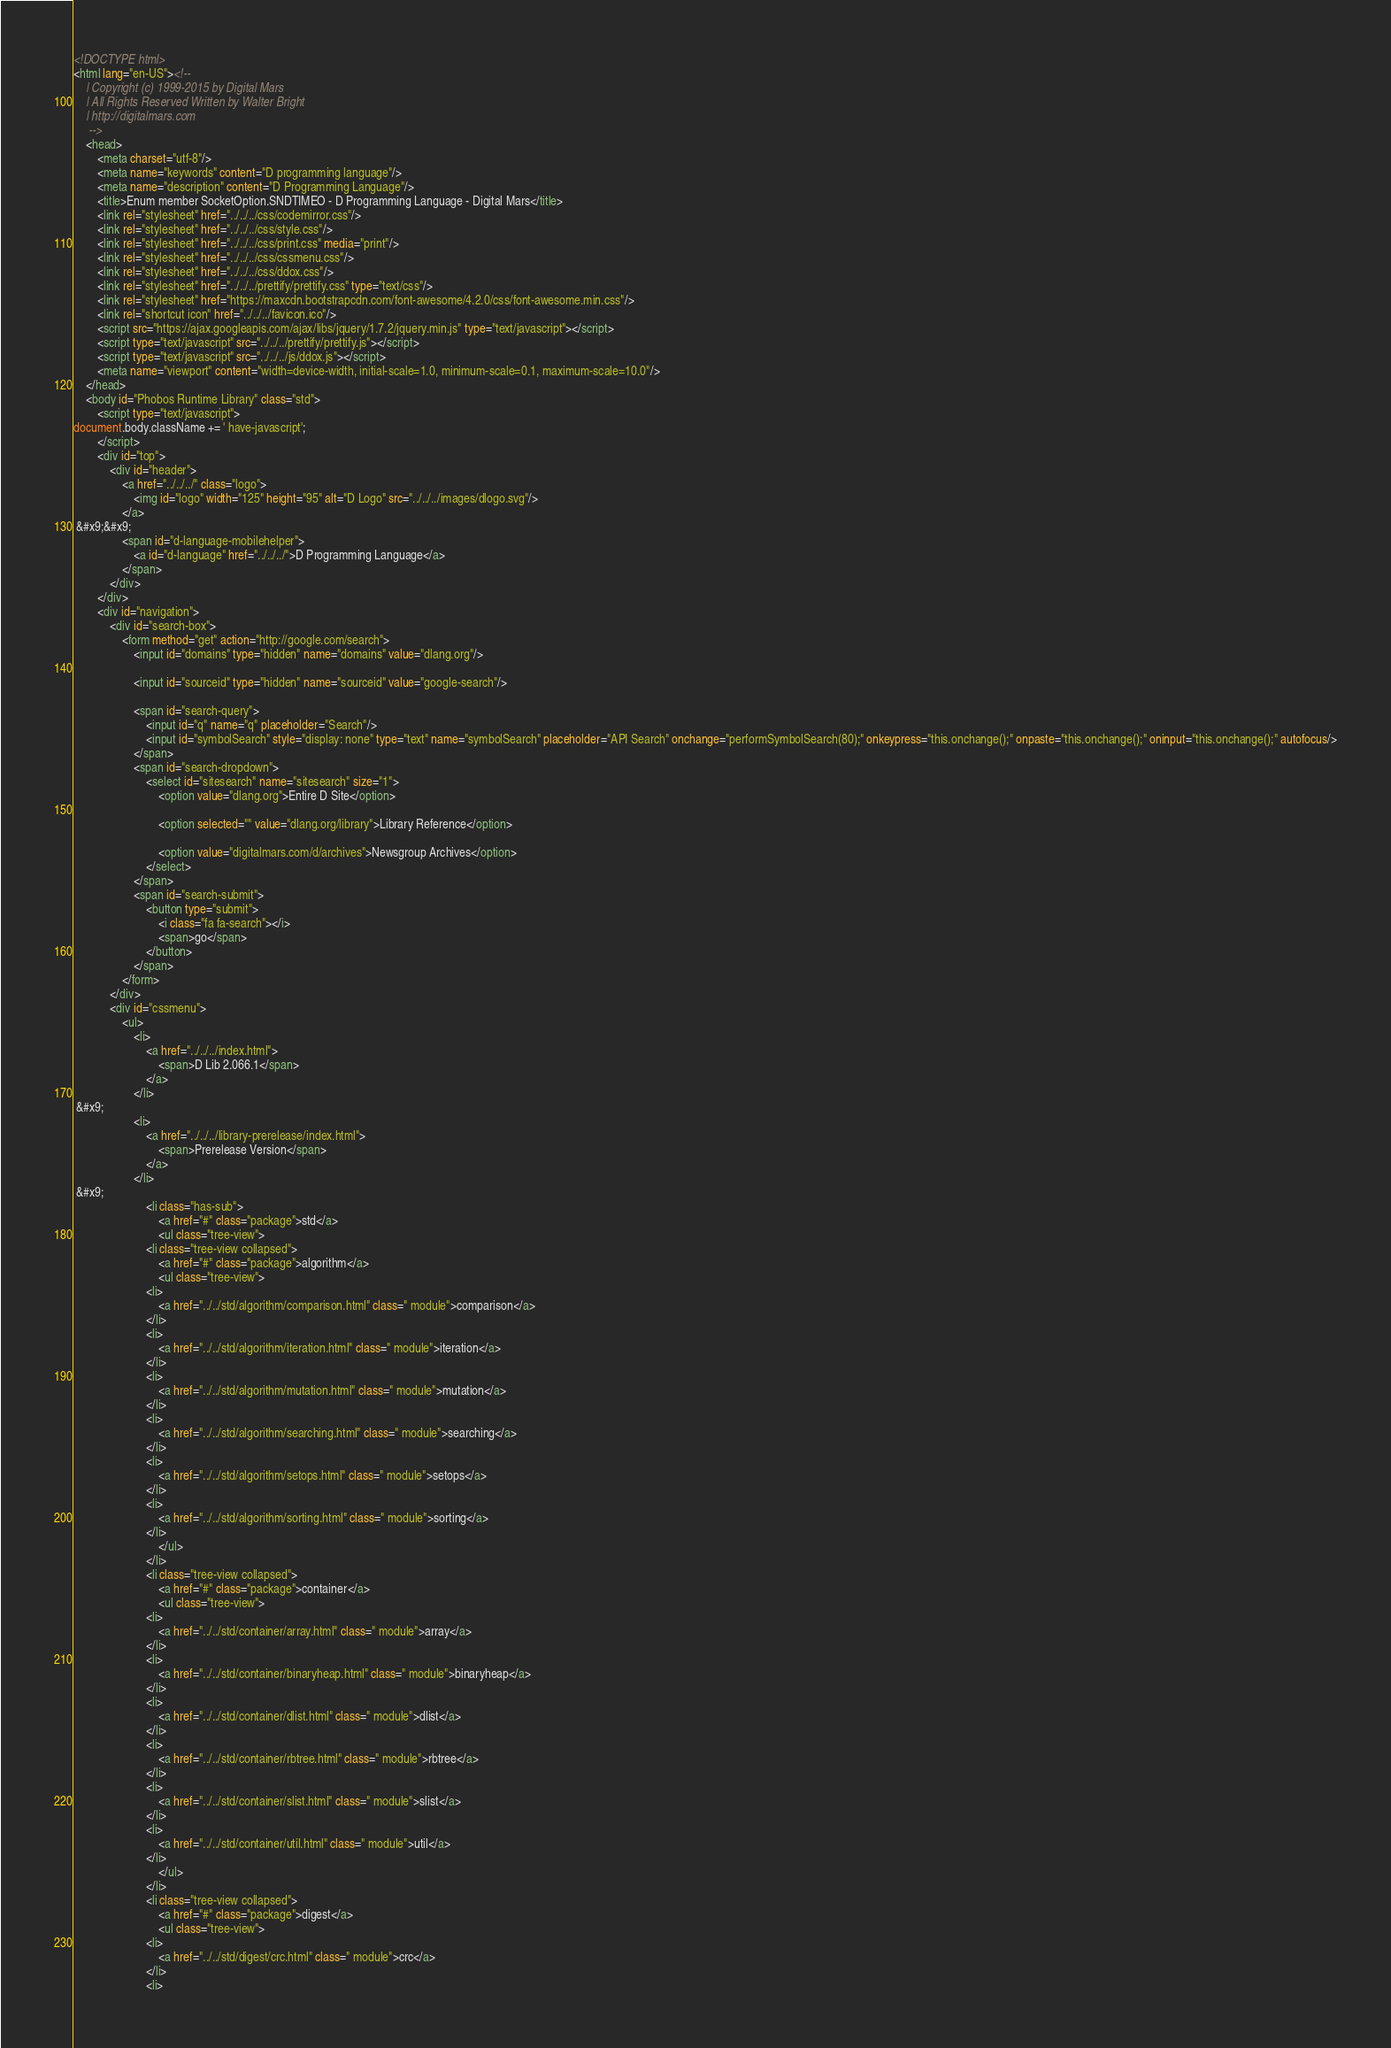Convert code to text. <code><loc_0><loc_0><loc_500><loc_500><_HTML_><!DOCTYPE html>
<html lang="en-US"><!-- 
    | Copyright (c) 1999-2015 by Digital Mars
    | All Rights Reserved Written by Walter Bright
    | http://digitalmars.com
	 -->
	<head>
		<meta charset="utf-8"/>
		<meta name="keywords" content="D programming language"/>
		<meta name="description" content="D Programming Language"/>
		<title>Enum member SocketOption.SNDTIMEO - D Programming Language - Digital Mars</title>
		<link rel="stylesheet" href="../../../css/codemirror.css"/>
		<link rel="stylesheet" href="../../../css/style.css"/>
		<link rel="stylesheet" href="../../../css/print.css" media="print"/>
		<link rel="stylesheet" href="../../../css/cssmenu.css"/>
		<link rel="stylesheet" href="../../../css/ddox.css"/>
		<link rel="stylesheet" href="../../../prettify/prettify.css" type="text/css"/>
		<link rel="stylesheet" href="https://maxcdn.bootstrapcdn.com/font-awesome/4.2.0/css/font-awesome.min.css"/>
		<link rel="shortcut icon" href="../../../favicon.ico"/>
		<script src="https://ajax.googleapis.com/ajax/libs/jquery/1.7.2/jquery.min.js" type="text/javascript"></script>
		<script type="text/javascript" src="../../../prettify/prettify.js"></script>
		<script type="text/javascript" src="../../../js/ddox.js"></script>
		<meta name="viewport" content="width=device-width, initial-scale=1.0, minimum-scale=0.1, maximum-scale=10.0"/>
	</head>
	<body id="Phobos Runtime Library" class="std">
		<script type="text/javascript">
document.body.className += ' have-javascript';
		</script>
		<div id="top">
			<div id="header">
				<a href="../../../" class="logo">
					<img id="logo" width="125" height="95" alt="D Logo" src="../../../images/dlogo.svg"/>
				</a>
 &#x9;&#x9;
				<span id="d-language-mobilehelper">
					<a id="d-language" href="../../../">D Programming Language</a>
				</span>
			</div>
		</div>
		<div id="navigation">
			<div id="search-box">
				<form method="get" action="http://google.com/search">
					<input id="domains" type="hidden" name="domains" value="dlang.org"/>
             
					<input id="sourceid" type="hidden" name="sourceid" value="google-search"/>
             
					<span id="search-query">
						<input id="q" name="q" placeholder="Search"/>
						<input id="symbolSearch" style="display: none" type="text" name="symbolSearch" placeholder="API Search" onchange="performSymbolSearch(80);" onkeypress="this.onchange();" onpaste="this.onchange();" oninput="this.onchange();" autofocus/>
					</span>
					<span id="search-dropdown">
						<select id="sitesearch" name="sitesearch" size="1">
							<option value="dlang.org">Entire D Site</option>
                     
							<option selected="" value="dlang.org/library">Library Reference</option>
                     
							<option value="digitalmars.com/d/archives">Newsgroup Archives</option>
						</select>
					</span>
					<span id="search-submit">
						<button type="submit">
							<i class="fa fa-search"></i>
							<span>go</span>
						</button>
					</span>
				</form>
			</div>
			<div id="cssmenu">
				<ul>
					<li>
						<a href="../../../index.html">
							<span>D Lib 2.066.1</span>
						</a>
					</li>
 &#x9;
					<li>
						<a href="../../../library-prerelease/index.html">
							<span>Prerelease Version</span>
						</a>
					</li>
 &#x9;
						<li class="has-sub">
							<a href="#" class="package">std</a>
							<ul class="tree-view">
						<li class="tree-view collapsed">
							<a href="#" class="package">algorithm</a>
							<ul class="tree-view">
						<li>
							<a href="../../std/algorithm/comparison.html" class=" module">comparison</a>
						</li>
						<li>
							<a href="../../std/algorithm/iteration.html" class=" module">iteration</a>
						</li>
						<li>
							<a href="../../std/algorithm/mutation.html" class=" module">mutation</a>
						</li>
						<li>
							<a href="../../std/algorithm/searching.html" class=" module">searching</a>
						</li>
						<li>
							<a href="../../std/algorithm/setops.html" class=" module">setops</a>
						</li>
						<li>
							<a href="../../std/algorithm/sorting.html" class=" module">sorting</a>
						</li>
							</ul>
						</li>
						<li class="tree-view collapsed">
							<a href="#" class="package">container</a>
							<ul class="tree-view">
						<li>
							<a href="../../std/container/array.html" class=" module">array</a>
						</li>
						<li>
							<a href="../../std/container/binaryheap.html" class=" module">binaryheap</a>
						</li>
						<li>
							<a href="../../std/container/dlist.html" class=" module">dlist</a>
						</li>
						<li>
							<a href="../../std/container/rbtree.html" class=" module">rbtree</a>
						</li>
						<li>
							<a href="../../std/container/slist.html" class=" module">slist</a>
						</li>
						<li>
							<a href="../../std/container/util.html" class=" module">util</a>
						</li>
							</ul>
						</li>
						<li class="tree-view collapsed">
							<a href="#" class="package">digest</a>
							<ul class="tree-view">
						<li>
							<a href="../../std/digest/crc.html" class=" module">crc</a>
						</li>
						<li></code> 